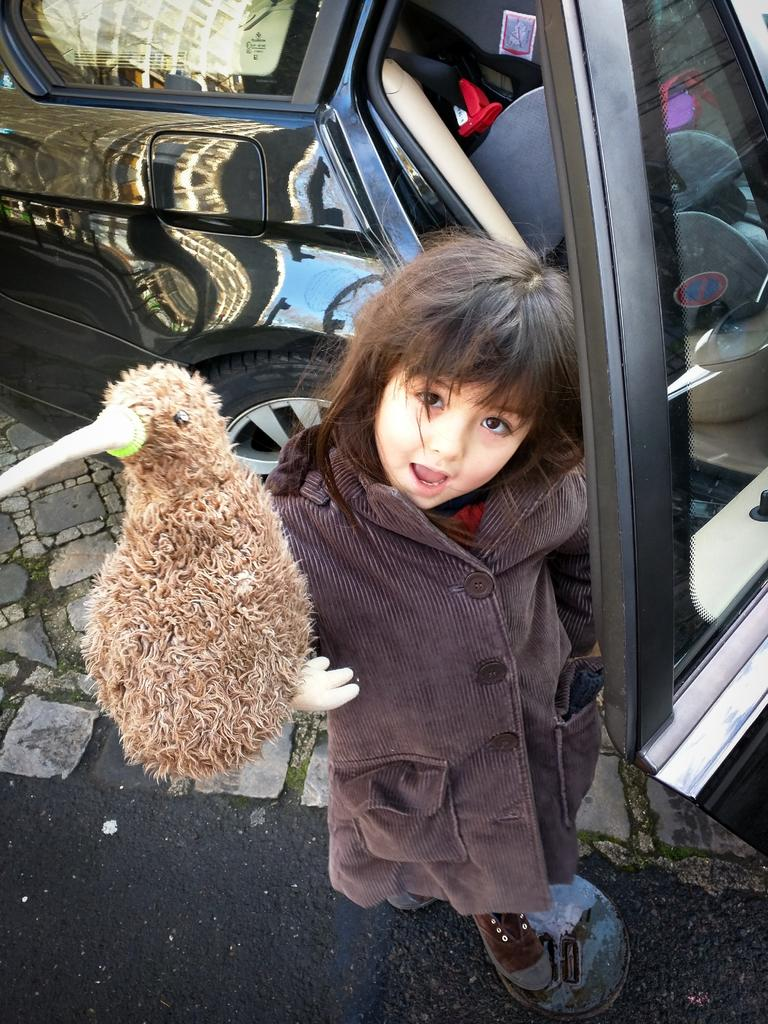Who is the main subject in the picture? There is a girl in the picture. What is the girl doing in the picture? The girl is standing and catching a bird. What is located behind the girl in the picture? There is a car behind the girl. How many boats are visible in the picture? There are no boats present in the picture; it features a girl catching a bird and a car behind her. What type of mint is being used as a garnish in the picture? There is no mint or any food item present in the picture. 